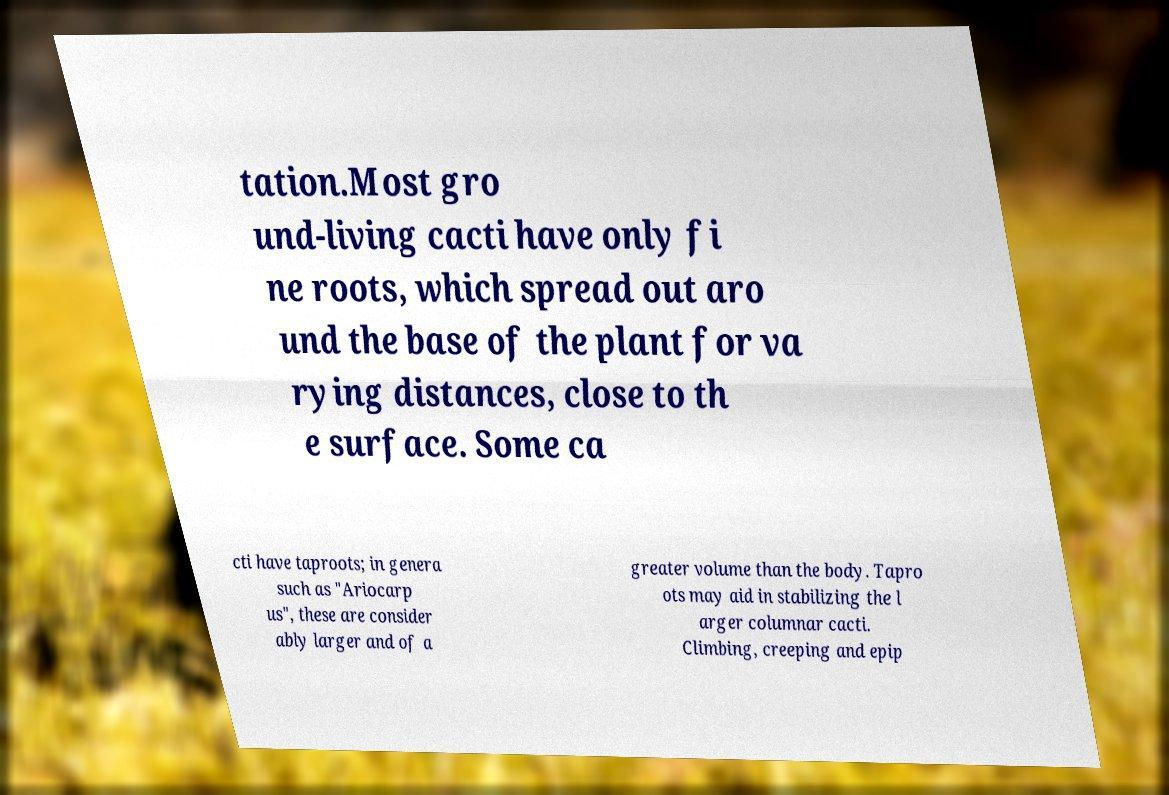Please read and relay the text visible in this image. What does it say? tation.Most gro und-living cacti have only fi ne roots, which spread out aro und the base of the plant for va rying distances, close to th e surface. Some ca cti have taproots; in genera such as "Ariocarp us", these are consider ably larger and of a greater volume than the body. Tapro ots may aid in stabilizing the l arger columnar cacti. Climbing, creeping and epip 